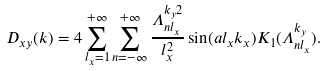Convert formula to latex. <formula><loc_0><loc_0><loc_500><loc_500>D _ { x y } ( { k } ) = 4 \sum _ { l _ { x } = 1 } ^ { + \infty } \sum _ { n = - \infty } ^ { + \infty } \frac { \Lambda _ { n l _ { x } } ^ { k _ { y } 2 } } { l _ { x } ^ { 2 } } \sin ( a l _ { x } k _ { x } ) K _ { 1 } ( \Lambda _ { n l _ { x } } ^ { k _ { y } } ) .</formula> 